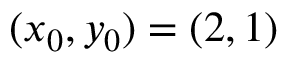<formula> <loc_0><loc_0><loc_500><loc_500>( x _ { 0 } , y _ { 0 } ) = ( 2 , 1 )</formula> 